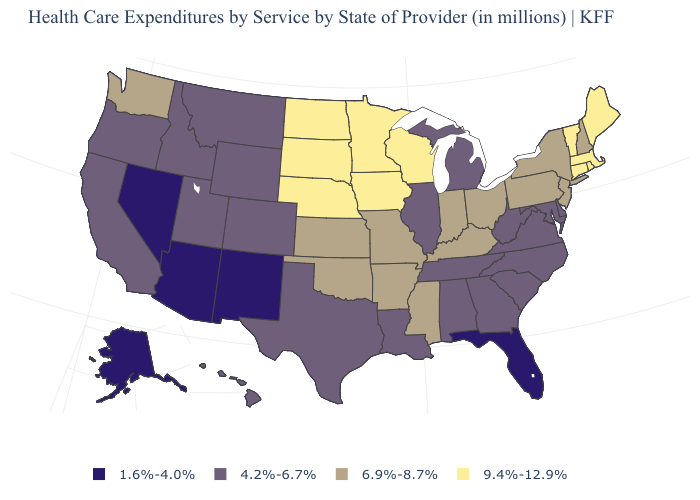Name the states that have a value in the range 4.2%-6.7%?
Be succinct. Alabama, California, Colorado, Delaware, Georgia, Hawaii, Idaho, Illinois, Louisiana, Maryland, Michigan, Montana, North Carolina, Oregon, South Carolina, Tennessee, Texas, Utah, Virginia, West Virginia, Wyoming. Name the states that have a value in the range 9.4%-12.9%?
Answer briefly. Connecticut, Iowa, Maine, Massachusetts, Minnesota, Nebraska, North Dakota, Rhode Island, South Dakota, Vermont, Wisconsin. How many symbols are there in the legend?
Be succinct. 4. Name the states that have a value in the range 4.2%-6.7%?
Keep it brief. Alabama, California, Colorado, Delaware, Georgia, Hawaii, Idaho, Illinois, Louisiana, Maryland, Michigan, Montana, North Carolina, Oregon, South Carolina, Tennessee, Texas, Utah, Virginia, West Virginia, Wyoming. Which states have the highest value in the USA?
Give a very brief answer. Connecticut, Iowa, Maine, Massachusetts, Minnesota, Nebraska, North Dakota, Rhode Island, South Dakota, Vermont, Wisconsin. What is the value of Nebraska?
Write a very short answer. 9.4%-12.9%. Does Washington have the highest value in the West?
Keep it brief. Yes. What is the value of Mississippi?
Be succinct. 6.9%-8.7%. Among the states that border Kentucky , which have the highest value?
Write a very short answer. Indiana, Missouri, Ohio. What is the value of Indiana?
Answer briefly. 6.9%-8.7%. Among the states that border North Carolina , which have the lowest value?
Be succinct. Georgia, South Carolina, Tennessee, Virginia. What is the value of Texas?
Answer briefly. 4.2%-6.7%. What is the highest value in the South ?
Keep it brief. 6.9%-8.7%. What is the highest value in states that border Minnesota?
Quick response, please. 9.4%-12.9%. 